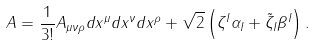Convert formula to latex. <formula><loc_0><loc_0><loc_500><loc_500>A = \frac { 1 } { 3 ! } A _ { \mu \nu \rho } d x ^ { \mu } d x ^ { \nu } d x ^ { \rho } + \sqrt { 2 } \left ( { \zeta ^ { I } \alpha _ { I } + \tilde { \zeta } _ { I } \beta ^ { I } } \right ) .</formula> 